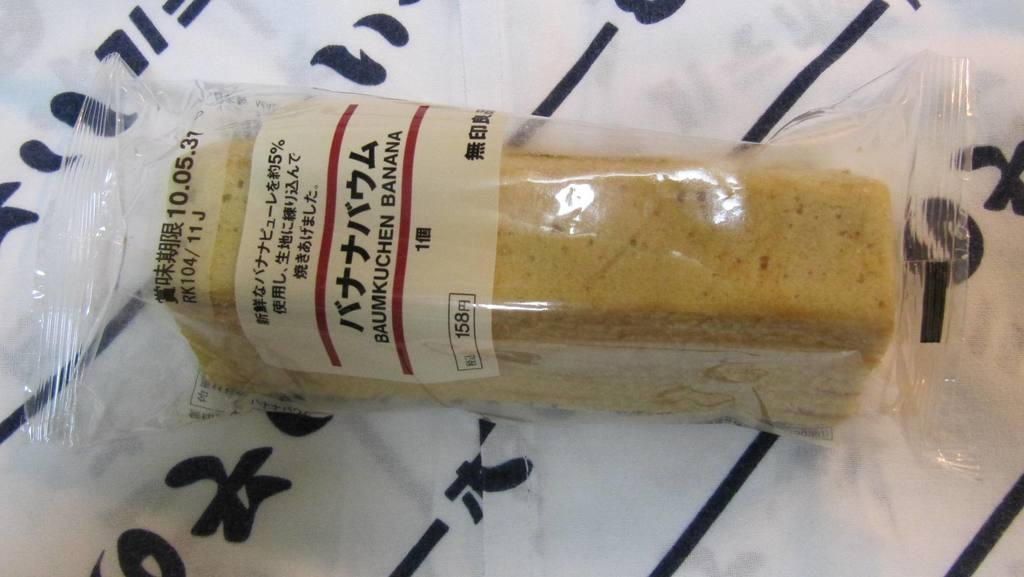<image>
Render a clear and concise summary of the photo. A food package with the word BAUMKUCHEN on it. 